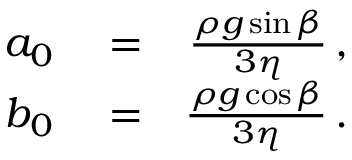<formula> <loc_0><loc_0><loc_500><loc_500>\begin{array} { r l r } { a _ { 0 } } & = } & { \frac { \rho g \sin \beta } { 3 \eta } \, , } \\ { b _ { 0 } } & = } & { \frac { \rho g \cos \beta } { 3 \eta } \, . } \end{array}</formula> 